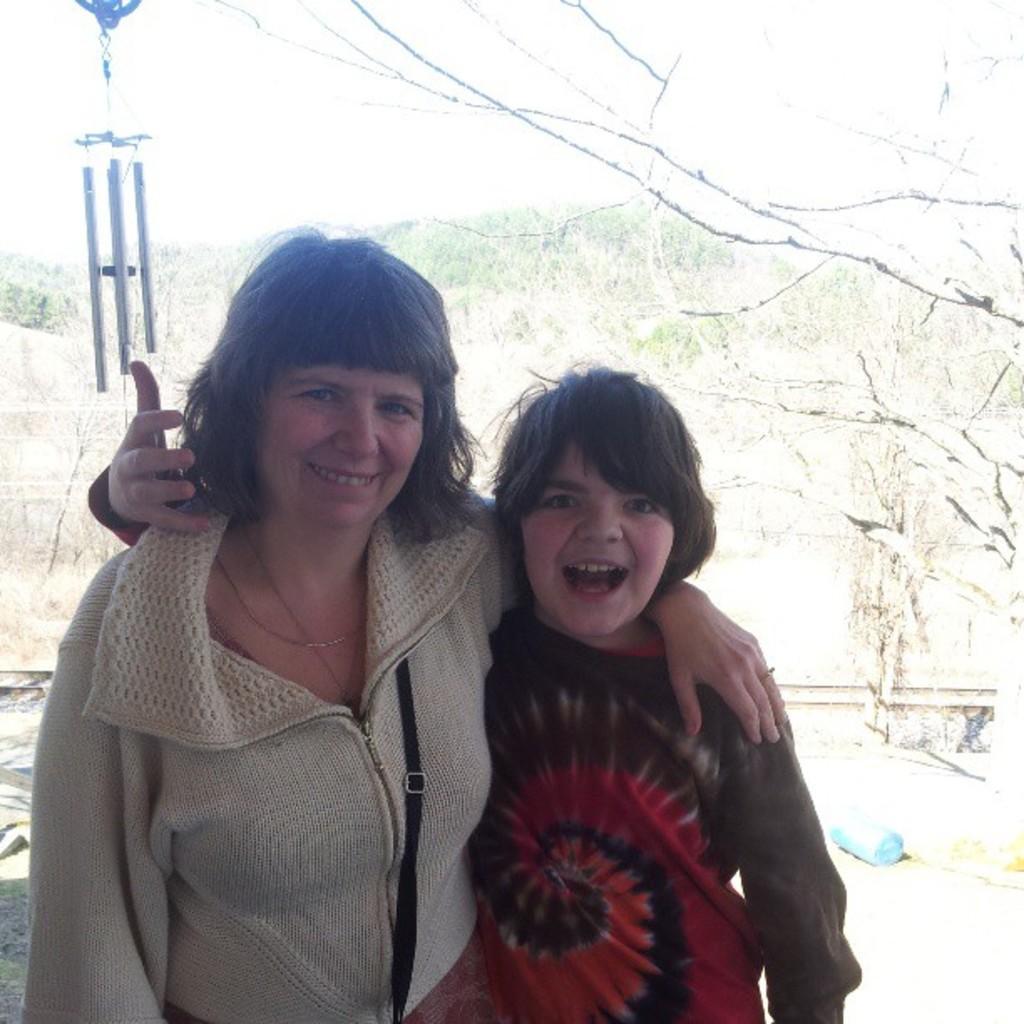Please provide a concise description of this image. In this image we can see a woman and a boy smiling. In the background, we can see the trees, fence, a blue color object and also the grass and some poles. We can also see the sky. 